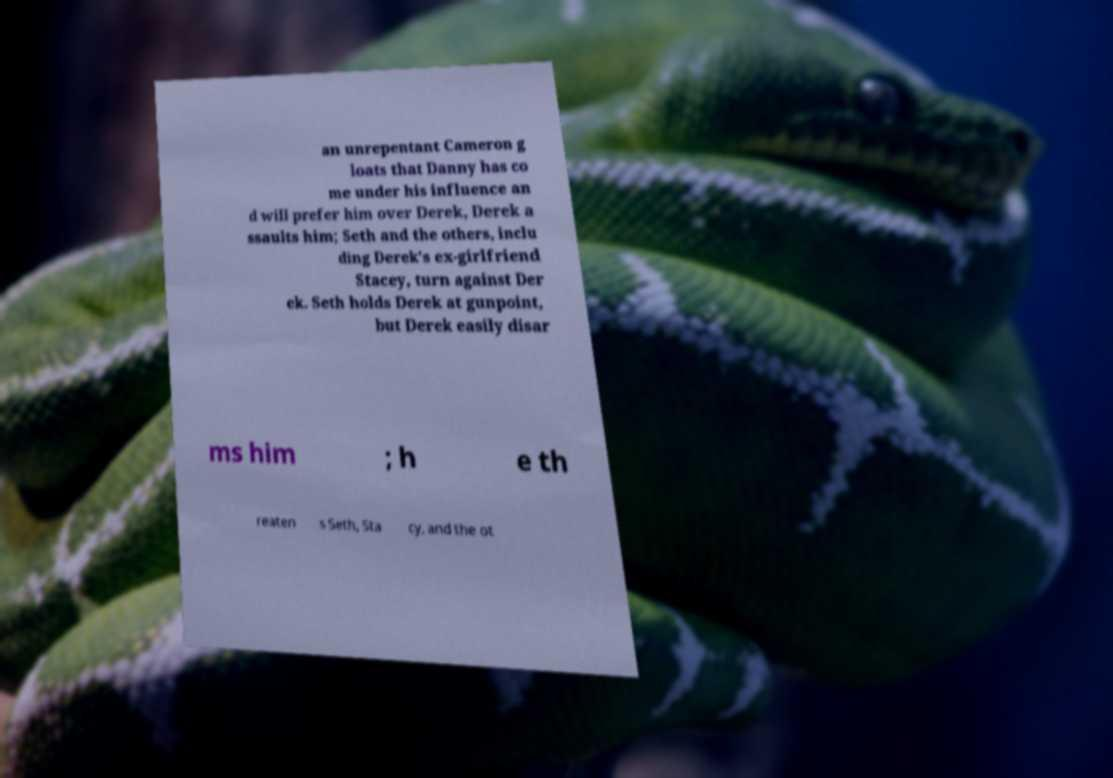Can you accurately transcribe the text from the provided image for me? an unrepentant Cameron g loats that Danny has co me under his influence an d will prefer him over Derek, Derek a ssaults him; Seth and the others, inclu ding Derek's ex-girlfriend Stacey, turn against Der ek. Seth holds Derek at gunpoint, but Derek easily disar ms him ; h e th reaten s Seth, Sta cy, and the ot 